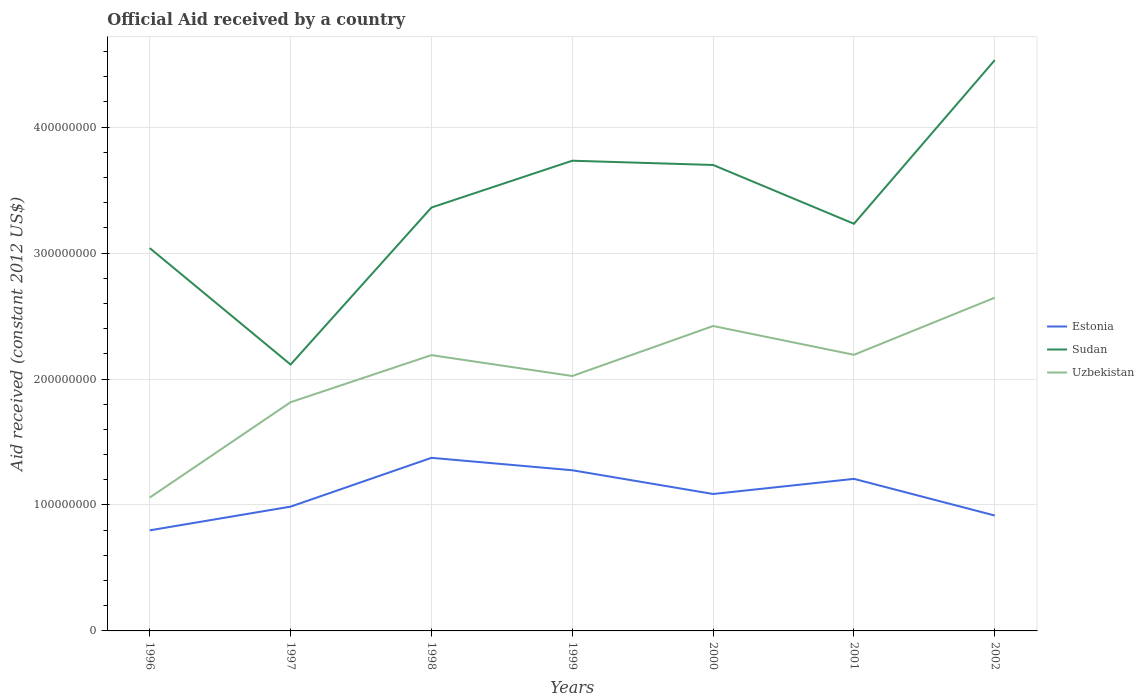Does the line corresponding to Estonia intersect with the line corresponding to Sudan?
Ensure brevity in your answer.  No. Across all years, what is the maximum net official aid received in Estonia?
Provide a short and direct response. 7.99e+07. What is the total net official aid received in Estonia in the graph?
Your answer should be compact. 1.67e+07. What is the difference between the highest and the second highest net official aid received in Estonia?
Offer a terse response. 5.76e+07. What is the difference between two consecutive major ticks on the Y-axis?
Offer a terse response. 1.00e+08. Does the graph contain any zero values?
Give a very brief answer. No. What is the title of the graph?
Make the answer very short. Official Aid received by a country. Does "Marshall Islands" appear as one of the legend labels in the graph?
Your response must be concise. No. What is the label or title of the Y-axis?
Provide a succinct answer. Aid received (constant 2012 US$). What is the Aid received (constant 2012 US$) in Estonia in 1996?
Make the answer very short. 7.99e+07. What is the Aid received (constant 2012 US$) in Sudan in 1996?
Your response must be concise. 3.04e+08. What is the Aid received (constant 2012 US$) of Uzbekistan in 1996?
Your answer should be compact. 1.06e+08. What is the Aid received (constant 2012 US$) in Estonia in 1997?
Provide a short and direct response. 9.87e+07. What is the Aid received (constant 2012 US$) of Sudan in 1997?
Provide a short and direct response. 2.12e+08. What is the Aid received (constant 2012 US$) of Uzbekistan in 1997?
Your answer should be compact. 1.82e+08. What is the Aid received (constant 2012 US$) in Estonia in 1998?
Offer a very short reply. 1.37e+08. What is the Aid received (constant 2012 US$) of Sudan in 1998?
Give a very brief answer. 3.36e+08. What is the Aid received (constant 2012 US$) of Uzbekistan in 1998?
Ensure brevity in your answer.  2.19e+08. What is the Aid received (constant 2012 US$) of Estonia in 1999?
Provide a short and direct response. 1.28e+08. What is the Aid received (constant 2012 US$) in Sudan in 1999?
Your answer should be very brief. 3.73e+08. What is the Aid received (constant 2012 US$) of Uzbekistan in 1999?
Ensure brevity in your answer.  2.02e+08. What is the Aid received (constant 2012 US$) in Estonia in 2000?
Give a very brief answer. 1.09e+08. What is the Aid received (constant 2012 US$) of Sudan in 2000?
Your answer should be compact. 3.70e+08. What is the Aid received (constant 2012 US$) in Uzbekistan in 2000?
Your answer should be compact. 2.42e+08. What is the Aid received (constant 2012 US$) in Estonia in 2001?
Provide a short and direct response. 1.21e+08. What is the Aid received (constant 2012 US$) of Sudan in 2001?
Offer a very short reply. 3.23e+08. What is the Aid received (constant 2012 US$) in Uzbekistan in 2001?
Provide a succinct answer. 2.19e+08. What is the Aid received (constant 2012 US$) in Estonia in 2002?
Offer a very short reply. 9.16e+07. What is the Aid received (constant 2012 US$) in Sudan in 2002?
Make the answer very short. 4.53e+08. What is the Aid received (constant 2012 US$) of Uzbekistan in 2002?
Make the answer very short. 2.65e+08. Across all years, what is the maximum Aid received (constant 2012 US$) of Estonia?
Provide a short and direct response. 1.37e+08. Across all years, what is the maximum Aid received (constant 2012 US$) in Sudan?
Offer a terse response. 4.53e+08. Across all years, what is the maximum Aid received (constant 2012 US$) in Uzbekistan?
Provide a succinct answer. 2.65e+08. Across all years, what is the minimum Aid received (constant 2012 US$) in Estonia?
Give a very brief answer. 7.99e+07. Across all years, what is the minimum Aid received (constant 2012 US$) of Sudan?
Give a very brief answer. 2.12e+08. Across all years, what is the minimum Aid received (constant 2012 US$) in Uzbekistan?
Provide a short and direct response. 1.06e+08. What is the total Aid received (constant 2012 US$) in Estonia in the graph?
Give a very brief answer. 7.65e+08. What is the total Aid received (constant 2012 US$) in Sudan in the graph?
Make the answer very short. 2.37e+09. What is the total Aid received (constant 2012 US$) in Uzbekistan in the graph?
Your response must be concise. 1.43e+09. What is the difference between the Aid received (constant 2012 US$) of Estonia in 1996 and that in 1997?
Your response must be concise. -1.88e+07. What is the difference between the Aid received (constant 2012 US$) in Sudan in 1996 and that in 1997?
Provide a short and direct response. 9.25e+07. What is the difference between the Aid received (constant 2012 US$) of Uzbekistan in 1996 and that in 1997?
Offer a terse response. -7.57e+07. What is the difference between the Aid received (constant 2012 US$) of Estonia in 1996 and that in 1998?
Provide a short and direct response. -5.76e+07. What is the difference between the Aid received (constant 2012 US$) in Sudan in 1996 and that in 1998?
Provide a succinct answer. -3.22e+07. What is the difference between the Aid received (constant 2012 US$) in Uzbekistan in 1996 and that in 1998?
Your answer should be very brief. -1.13e+08. What is the difference between the Aid received (constant 2012 US$) in Estonia in 1996 and that in 1999?
Offer a terse response. -4.77e+07. What is the difference between the Aid received (constant 2012 US$) of Sudan in 1996 and that in 1999?
Your answer should be compact. -6.94e+07. What is the difference between the Aid received (constant 2012 US$) in Uzbekistan in 1996 and that in 1999?
Your answer should be compact. -9.65e+07. What is the difference between the Aid received (constant 2012 US$) in Estonia in 1996 and that in 2000?
Your answer should be compact. -2.89e+07. What is the difference between the Aid received (constant 2012 US$) of Sudan in 1996 and that in 2000?
Your answer should be very brief. -6.60e+07. What is the difference between the Aid received (constant 2012 US$) in Uzbekistan in 1996 and that in 2000?
Keep it short and to the point. -1.36e+08. What is the difference between the Aid received (constant 2012 US$) of Estonia in 1996 and that in 2001?
Offer a terse response. -4.09e+07. What is the difference between the Aid received (constant 2012 US$) in Sudan in 1996 and that in 2001?
Provide a short and direct response. -1.93e+07. What is the difference between the Aid received (constant 2012 US$) of Uzbekistan in 1996 and that in 2001?
Give a very brief answer. -1.13e+08. What is the difference between the Aid received (constant 2012 US$) of Estonia in 1996 and that in 2002?
Your answer should be compact. -1.18e+07. What is the difference between the Aid received (constant 2012 US$) of Sudan in 1996 and that in 2002?
Give a very brief answer. -1.49e+08. What is the difference between the Aid received (constant 2012 US$) in Uzbekistan in 1996 and that in 2002?
Give a very brief answer. -1.59e+08. What is the difference between the Aid received (constant 2012 US$) of Estonia in 1997 and that in 1998?
Your answer should be very brief. -3.88e+07. What is the difference between the Aid received (constant 2012 US$) in Sudan in 1997 and that in 1998?
Offer a very short reply. -1.25e+08. What is the difference between the Aid received (constant 2012 US$) in Uzbekistan in 1997 and that in 1998?
Keep it short and to the point. -3.74e+07. What is the difference between the Aid received (constant 2012 US$) of Estonia in 1997 and that in 1999?
Offer a terse response. -2.89e+07. What is the difference between the Aid received (constant 2012 US$) of Sudan in 1997 and that in 1999?
Your response must be concise. -1.62e+08. What is the difference between the Aid received (constant 2012 US$) in Uzbekistan in 1997 and that in 1999?
Ensure brevity in your answer.  -2.08e+07. What is the difference between the Aid received (constant 2012 US$) of Estonia in 1997 and that in 2000?
Your answer should be very brief. -1.00e+07. What is the difference between the Aid received (constant 2012 US$) in Sudan in 1997 and that in 2000?
Keep it short and to the point. -1.58e+08. What is the difference between the Aid received (constant 2012 US$) in Uzbekistan in 1997 and that in 2000?
Give a very brief answer. -6.05e+07. What is the difference between the Aid received (constant 2012 US$) in Estonia in 1997 and that in 2001?
Ensure brevity in your answer.  -2.20e+07. What is the difference between the Aid received (constant 2012 US$) of Sudan in 1997 and that in 2001?
Offer a very short reply. -1.12e+08. What is the difference between the Aid received (constant 2012 US$) in Uzbekistan in 1997 and that in 2001?
Offer a very short reply. -3.76e+07. What is the difference between the Aid received (constant 2012 US$) of Estonia in 1997 and that in 2002?
Make the answer very short. 7.07e+06. What is the difference between the Aid received (constant 2012 US$) in Sudan in 1997 and that in 2002?
Your answer should be very brief. -2.42e+08. What is the difference between the Aid received (constant 2012 US$) of Uzbekistan in 1997 and that in 2002?
Your answer should be very brief. -8.30e+07. What is the difference between the Aid received (constant 2012 US$) of Estonia in 1998 and that in 1999?
Provide a succinct answer. 9.86e+06. What is the difference between the Aid received (constant 2012 US$) of Sudan in 1998 and that in 1999?
Give a very brief answer. -3.72e+07. What is the difference between the Aid received (constant 2012 US$) in Uzbekistan in 1998 and that in 1999?
Provide a short and direct response. 1.66e+07. What is the difference between the Aid received (constant 2012 US$) of Estonia in 1998 and that in 2000?
Make the answer very short. 2.87e+07. What is the difference between the Aid received (constant 2012 US$) of Sudan in 1998 and that in 2000?
Your response must be concise. -3.38e+07. What is the difference between the Aid received (constant 2012 US$) in Uzbekistan in 1998 and that in 2000?
Your answer should be compact. -2.31e+07. What is the difference between the Aid received (constant 2012 US$) of Estonia in 1998 and that in 2001?
Your response must be concise. 1.67e+07. What is the difference between the Aid received (constant 2012 US$) of Sudan in 1998 and that in 2001?
Offer a terse response. 1.29e+07. What is the difference between the Aid received (constant 2012 US$) in Uzbekistan in 1998 and that in 2001?
Your answer should be very brief. -2.70e+05. What is the difference between the Aid received (constant 2012 US$) in Estonia in 1998 and that in 2002?
Give a very brief answer. 4.58e+07. What is the difference between the Aid received (constant 2012 US$) of Sudan in 1998 and that in 2002?
Your answer should be compact. -1.17e+08. What is the difference between the Aid received (constant 2012 US$) in Uzbekistan in 1998 and that in 2002?
Keep it short and to the point. -4.56e+07. What is the difference between the Aid received (constant 2012 US$) of Estonia in 1999 and that in 2000?
Make the answer very short. 1.88e+07. What is the difference between the Aid received (constant 2012 US$) of Sudan in 1999 and that in 2000?
Give a very brief answer. 3.39e+06. What is the difference between the Aid received (constant 2012 US$) of Uzbekistan in 1999 and that in 2000?
Your answer should be compact. -3.97e+07. What is the difference between the Aid received (constant 2012 US$) of Estonia in 1999 and that in 2001?
Provide a short and direct response. 6.84e+06. What is the difference between the Aid received (constant 2012 US$) in Sudan in 1999 and that in 2001?
Your response must be concise. 5.01e+07. What is the difference between the Aid received (constant 2012 US$) of Uzbekistan in 1999 and that in 2001?
Make the answer very short. -1.68e+07. What is the difference between the Aid received (constant 2012 US$) in Estonia in 1999 and that in 2002?
Keep it short and to the point. 3.60e+07. What is the difference between the Aid received (constant 2012 US$) of Sudan in 1999 and that in 2002?
Ensure brevity in your answer.  -7.99e+07. What is the difference between the Aid received (constant 2012 US$) of Uzbekistan in 1999 and that in 2002?
Provide a succinct answer. -6.22e+07. What is the difference between the Aid received (constant 2012 US$) of Estonia in 2000 and that in 2001?
Ensure brevity in your answer.  -1.20e+07. What is the difference between the Aid received (constant 2012 US$) in Sudan in 2000 and that in 2001?
Provide a succinct answer. 4.67e+07. What is the difference between the Aid received (constant 2012 US$) in Uzbekistan in 2000 and that in 2001?
Provide a succinct answer. 2.29e+07. What is the difference between the Aid received (constant 2012 US$) in Estonia in 2000 and that in 2002?
Ensure brevity in your answer.  1.71e+07. What is the difference between the Aid received (constant 2012 US$) in Sudan in 2000 and that in 2002?
Make the answer very short. -8.33e+07. What is the difference between the Aid received (constant 2012 US$) of Uzbekistan in 2000 and that in 2002?
Give a very brief answer. -2.25e+07. What is the difference between the Aid received (constant 2012 US$) in Estonia in 2001 and that in 2002?
Offer a terse response. 2.91e+07. What is the difference between the Aid received (constant 2012 US$) in Sudan in 2001 and that in 2002?
Your response must be concise. -1.30e+08. What is the difference between the Aid received (constant 2012 US$) of Uzbekistan in 2001 and that in 2002?
Provide a succinct answer. -4.54e+07. What is the difference between the Aid received (constant 2012 US$) in Estonia in 1996 and the Aid received (constant 2012 US$) in Sudan in 1997?
Keep it short and to the point. -1.32e+08. What is the difference between the Aid received (constant 2012 US$) in Estonia in 1996 and the Aid received (constant 2012 US$) in Uzbekistan in 1997?
Make the answer very short. -1.02e+08. What is the difference between the Aid received (constant 2012 US$) of Sudan in 1996 and the Aid received (constant 2012 US$) of Uzbekistan in 1997?
Your response must be concise. 1.22e+08. What is the difference between the Aid received (constant 2012 US$) of Estonia in 1996 and the Aid received (constant 2012 US$) of Sudan in 1998?
Ensure brevity in your answer.  -2.56e+08. What is the difference between the Aid received (constant 2012 US$) in Estonia in 1996 and the Aid received (constant 2012 US$) in Uzbekistan in 1998?
Give a very brief answer. -1.39e+08. What is the difference between the Aid received (constant 2012 US$) of Sudan in 1996 and the Aid received (constant 2012 US$) of Uzbekistan in 1998?
Offer a terse response. 8.50e+07. What is the difference between the Aid received (constant 2012 US$) in Estonia in 1996 and the Aid received (constant 2012 US$) in Sudan in 1999?
Ensure brevity in your answer.  -2.94e+08. What is the difference between the Aid received (constant 2012 US$) in Estonia in 1996 and the Aid received (constant 2012 US$) in Uzbekistan in 1999?
Make the answer very short. -1.23e+08. What is the difference between the Aid received (constant 2012 US$) of Sudan in 1996 and the Aid received (constant 2012 US$) of Uzbekistan in 1999?
Your answer should be compact. 1.02e+08. What is the difference between the Aid received (constant 2012 US$) of Estonia in 1996 and the Aid received (constant 2012 US$) of Sudan in 2000?
Offer a terse response. -2.90e+08. What is the difference between the Aid received (constant 2012 US$) of Estonia in 1996 and the Aid received (constant 2012 US$) of Uzbekistan in 2000?
Keep it short and to the point. -1.62e+08. What is the difference between the Aid received (constant 2012 US$) of Sudan in 1996 and the Aid received (constant 2012 US$) of Uzbekistan in 2000?
Keep it short and to the point. 6.18e+07. What is the difference between the Aid received (constant 2012 US$) of Estonia in 1996 and the Aid received (constant 2012 US$) of Sudan in 2001?
Your answer should be very brief. -2.43e+08. What is the difference between the Aid received (constant 2012 US$) in Estonia in 1996 and the Aid received (constant 2012 US$) in Uzbekistan in 2001?
Offer a terse response. -1.39e+08. What is the difference between the Aid received (constant 2012 US$) of Sudan in 1996 and the Aid received (constant 2012 US$) of Uzbekistan in 2001?
Keep it short and to the point. 8.47e+07. What is the difference between the Aid received (constant 2012 US$) of Estonia in 1996 and the Aid received (constant 2012 US$) of Sudan in 2002?
Offer a very short reply. -3.73e+08. What is the difference between the Aid received (constant 2012 US$) in Estonia in 1996 and the Aid received (constant 2012 US$) in Uzbekistan in 2002?
Your answer should be compact. -1.85e+08. What is the difference between the Aid received (constant 2012 US$) of Sudan in 1996 and the Aid received (constant 2012 US$) of Uzbekistan in 2002?
Your answer should be very brief. 3.93e+07. What is the difference between the Aid received (constant 2012 US$) in Estonia in 1997 and the Aid received (constant 2012 US$) in Sudan in 1998?
Make the answer very short. -2.38e+08. What is the difference between the Aid received (constant 2012 US$) in Estonia in 1997 and the Aid received (constant 2012 US$) in Uzbekistan in 1998?
Your answer should be very brief. -1.20e+08. What is the difference between the Aid received (constant 2012 US$) in Sudan in 1997 and the Aid received (constant 2012 US$) in Uzbekistan in 1998?
Give a very brief answer. -7.48e+06. What is the difference between the Aid received (constant 2012 US$) in Estonia in 1997 and the Aid received (constant 2012 US$) in Sudan in 1999?
Provide a short and direct response. -2.75e+08. What is the difference between the Aid received (constant 2012 US$) in Estonia in 1997 and the Aid received (constant 2012 US$) in Uzbekistan in 1999?
Give a very brief answer. -1.04e+08. What is the difference between the Aid received (constant 2012 US$) in Sudan in 1997 and the Aid received (constant 2012 US$) in Uzbekistan in 1999?
Give a very brief answer. 9.10e+06. What is the difference between the Aid received (constant 2012 US$) of Estonia in 1997 and the Aid received (constant 2012 US$) of Sudan in 2000?
Provide a short and direct response. -2.71e+08. What is the difference between the Aid received (constant 2012 US$) in Estonia in 1997 and the Aid received (constant 2012 US$) in Uzbekistan in 2000?
Provide a short and direct response. -1.43e+08. What is the difference between the Aid received (constant 2012 US$) of Sudan in 1997 and the Aid received (constant 2012 US$) of Uzbekistan in 2000?
Make the answer very short. -3.06e+07. What is the difference between the Aid received (constant 2012 US$) of Estonia in 1997 and the Aid received (constant 2012 US$) of Sudan in 2001?
Make the answer very short. -2.25e+08. What is the difference between the Aid received (constant 2012 US$) in Estonia in 1997 and the Aid received (constant 2012 US$) in Uzbekistan in 2001?
Ensure brevity in your answer.  -1.21e+08. What is the difference between the Aid received (constant 2012 US$) in Sudan in 1997 and the Aid received (constant 2012 US$) in Uzbekistan in 2001?
Make the answer very short. -7.75e+06. What is the difference between the Aid received (constant 2012 US$) of Estonia in 1997 and the Aid received (constant 2012 US$) of Sudan in 2002?
Keep it short and to the point. -3.55e+08. What is the difference between the Aid received (constant 2012 US$) in Estonia in 1997 and the Aid received (constant 2012 US$) in Uzbekistan in 2002?
Offer a very short reply. -1.66e+08. What is the difference between the Aid received (constant 2012 US$) in Sudan in 1997 and the Aid received (constant 2012 US$) in Uzbekistan in 2002?
Ensure brevity in your answer.  -5.31e+07. What is the difference between the Aid received (constant 2012 US$) in Estonia in 1998 and the Aid received (constant 2012 US$) in Sudan in 1999?
Offer a very short reply. -2.36e+08. What is the difference between the Aid received (constant 2012 US$) of Estonia in 1998 and the Aid received (constant 2012 US$) of Uzbekistan in 1999?
Your answer should be compact. -6.50e+07. What is the difference between the Aid received (constant 2012 US$) in Sudan in 1998 and the Aid received (constant 2012 US$) in Uzbekistan in 1999?
Provide a short and direct response. 1.34e+08. What is the difference between the Aid received (constant 2012 US$) in Estonia in 1998 and the Aid received (constant 2012 US$) in Sudan in 2000?
Your response must be concise. -2.33e+08. What is the difference between the Aid received (constant 2012 US$) of Estonia in 1998 and the Aid received (constant 2012 US$) of Uzbekistan in 2000?
Make the answer very short. -1.05e+08. What is the difference between the Aid received (constant 2012 US$) of Sudan in 1998 and the Aid received (constant 2012 US$) of Uzbekistan in 2000?
Offer a very short reply. 9.41e+07. What is the difference between the Aid received (constant 2012 US$) of Estonia in 1998 and the Aid received (constant 2012 US$) of Sudan in 2001?
Provide a short and direct response. -1.86e+08. What is the difference between the Aid received (constant 2012 US$) in Estonia in 1998 and the Aid received (constant 2012 US$) in Uzbekistan in 2001?
Make the answer very short. -8.18e+07. What is the difference between the Aid received (constant 2012 US$) of Sudan in 1998 and the Aid received (constant 2012 US$) of Uzbekistan in 2001?
Provide a succinct answer. 1.17e+08. What is the difference between the Aid received (constant 2012 US$) in Estonia in 1998 and the Aid received (constant 2012 US$) in Sudan in 2002?
Make the answer very short. -3.16e+08. What is the difference between the Aid received (constant 2012 US$) of Estonia in 1998 and the Aid received (constant 2012 US$) of Uzbekistan in 2002?
Offer a terse response. -1.27e+08. What is the difference between the Aid received (constant 2012 US$) of Sudan in 1998 and the Aid received (constant 2012 US$) of Uzbekistan in 2002?
Make the answer very short. 7.16e+07. What is the difference between the Aid received (constant 2012 US$) in Estonia in 1999 and the Aid received (constant 2012 US$) in Sudan in 2000?
Your response must be concise. -2.42e+08. What is the difference between the Aid received (constant 2012 US$) in Estonia in 1999 and the Aid received (constant 2012 US$) in Uzbekistan in 2000?
Your answer should be very brief. -1.15e+08. What is the difference between the Aid received (constant 2012 US$) in Sudan in 1999 and the Aid received (constant 2012 US$) in Uzbekistan in 2000?
Provide a short and direct response. 1.31e+08. What is the difference between the Aid received (constant 2012 US$) of Estonia in 1999 and the Aid received (constant 2012 US$) of Sudan in 2001?
Provide a succinct answer. -1.96e+08. What is the difference between the Aid received (constant 2012 US$) in Estonia in 1999 and the Aid received (constant 2012 US$) in Uzbekistan in 2001?
Provide a succinct answer. -9.17e+07. What is the difference between the Aid received (constant 2012 US$) in Sudan in 1999 and the Aid received (constant 2012 US$) in Uzbekistan in 2001?
Offer a very short reply. 1.54e+08. What is the difference between the Aid received (constant 2012 US$) of Estonia in 1999 and the Aid received (constant 2012 US$) of Sudan in 2002?
Your answer should be compact. -3.26e+08. What is the difference between the Aid received (constant 2012 US$) in Estonia in 1999 and the Aid received (constant 2012 US$) in Uzbekistan in 2002?
Your answer should be compact. -1.37e+08. What is the difference between the Aid received (constant 2012 US$) in Sudan in 1999 and the Aid received (constant 2012 US$) in Uzbekistan in 2002?
Ensure brevity in your answer.  1.09e+08. What is the difference between the Aid received (constant 2012 US$) of Estonia in 2000 and the Aid received (constant 2012 US$) of Sudan in 2001?
Your answer should be compact. -2.15e+08. What is the difference between the Aid received (constant 2012 US$) of Estonia in 2000 and the Aid received (constant 2012 US$) of Uzbekistan in 2001?
Ensure brevity in your answer.  -1.11e+08. What is the difference between the Aid received (constant 2012 US$) in Sudan in 2000 and the Aid received (constant 2012 US$) in Uzbekistan in 2001?
Ensure brevity in your answer.  1.51e+08. What is the difference between the Aid received (constant 2012 US$) in Estonia in 2000 and the Aid received (constant 2012 US$) in Sudan in 2002?
Provide a succinct answer. -3.45e+08. What is the difference between the Aid received (constant 2012 US$) in Estonia in 2000 and the Aid received (constant 2012 US$) in Uzbekistan in 2002?
Your response must be concise. -1.56e+08. What is the difference between the Aid received (constant 2012 US$) of Sudan in 2000 and the Aid received (constant 2012 US$) of Uzbekistan in 2002?
Provide a short and direct response. 1.05e+08. What is the difference between the Aid received (constant 2012 US$) of Estonia in 2001 and the Aid received (constant 2012 US$) of Sudan in 2002?
Offer a terse response. -3.33e+08. What is the difference between the Aid received (constant 2012 US$) in Estonia in 2001 and the Aid received (constant 2012 US$) in Uzbekistan in 2002?
Offer a terse response. -1.44e+08. What is the difference between the Aid received (constant 2012 US$) of Sudan in 2001 and the Aid received (constant 2012 US$) of Uzbekistan in 2002?
Make the answer very short. 5.87e+07. What is the average Aid received (constant 2012 US$) in Estonia per year?
Provide a succinct answer. 1.09e+08. What is the average Aid received (constant 2012 US$) in Sudan per year?
Your answer should be very brief. 3.39e+08. What is the average Aid received (constant 2012 US$) of Uzbekistan per year?
Your response must be concise. 2.05e+08. In the year 1996, what is the difference between the Aid received (constant 2012 US$) in Estonia and Aid received (constant 2012 US$) in Sudan?
Your answer should be very brief. -2.24e+08. In the year 1996, what is the difference between the Aid received (constant 2012 US$) of Estonia and Aid received (constant 2012 US$) of Uzbekistan?
Give a very brief answer. -2.60e+07. In the year 1996, what is the difference between the Aid received (constant 2012 US$) of Sudan and Aid received (constant 2012 US$) of Uzbekistan?
Make the answer very short. 1.98e+08. In the year 1997, what is the difference between the Aid received (constant 2012 US$) of Estonia and Aid received (constant 2012 US$) of Sudan?
Offer a terse response. -1.13e+08. In the year 1997, what is the difference between the Aid received (constant 2012 US$) of Estonia and Aid received (constant 2012 US$) of Uzbekistan?
Provide a succinct answer. -8.29e+07. In the year 1997, what is the difference between the Aid received (constant 2012 US$) of Sudan and Aid received (constant 2012 US$) of Uzbekistan?
Give a very brief answer. 2.99e+07. In the year 1998, what is the difference between the Aid received (constant 2012 US$) of Estonia and Aid received (constant 2012 US$) of Sudan?
Ensure brevity in your answer.  -1.99e+08. In the year 1998, what is the difference between the Aid received (constant 2012 US$) of Estonia and Aid received (constant 2012 US$) of Uzbekistan?
Offer a terse response. -8.16e+07. In the year 1998, what is the difference between the Aid received (constant 2012 US$) of Sudan and Aid received (constant 2012 US$) of Uzbekistan?
Your answer should be very brief. 1.17e+08. In the year 1999, what is the difference between the Aid received (constant 2012 US$) in Estonia and Aid received (constant 2012 US$) in Sudan?
Keep it short and to the point. -2.46e+08. In the year 1999, what is the difference between the Aid received (constant 2012 US$) in Estonia and Aid received (constant 2012 US$) in Uzbekistan?
Ensure brevity in your answer.  -7.48e+07. In the year 1999, what is the difference between the Aid received (constant 2012 US$) of Sudan and Aid received (constant 2012 US$) of Uzbekistan?
Your answer should be very brief. 1.71e+08. In the year 2000, what is the difference between the Aid received (constant 2012 US$) in Estonia and Aid received (constant 2012 US$) in Sudan?
Your answer should be compact. -2.61e+08. In the year 2000, what is the difference between the Aid received (constant 2012 US$) of Estonia and Aid received (constant 2012 US$) of Uzbekistan?
Your answer should be compact. -1.33e+08. In the year 2000, what is the difference between the Aid received (constant 2012 US$) of Sudan and Aid received (constant 2012 US$) of Uzbekistan?
Your response must be concise. 1.28e+08. In the year 2001, what is the difference between the Aid received (constant 2012 US$) of Estonia and Aid received (constant 2012 US$) of Sudan?
Provide a short and direct response. -2.03e+08. In the year 2001, what is the difference between the Aid received (constant 2012 US$) of Estonia and Aid received (constant 2012 US$) of Uzbekistan?
Offer a terse response. -9.85e+07. In the year 2001, what is the difference between the Aid received (constant 2012 US$) in Sudan and Aid received (constant 2012 US$) in Uzbekistan?
Offer a terse response. 1.04e+08. In the year 2002, what is the difference between the Aid received (constant 2012 US$) of Estonia and Aid received (constant 2012 US$) of Sudan?
Your answer should be compact. -3.62e+08. In the year 2002, what is the difference between the Aid received (constant 2012 US$) in Estonia and Aid received (constant 2012 US$) in Uzbekistan?
Your answer should be very brief. -1.73e+08. In the year 2002, what is the difference between the Aid received (constant 2012 US$) of Sudan and Aid received (constant 2012 US$) of Uzbekistan?
Offer a very short reply. 1.89e+08. What is the ratio of the Aid received (constant 2012 US$) of Estonia in 1996 to that in 1997?
Keep it short and to the point. 0.81. What is the ratio of the Aid received (constant 2012 US$) of Sudan in 1996 to that in 1997?
Your answer should be very brief. 1.44. What is the ratio of the Aid received (constant 2012 US$) in Uzbekistan in 1996 to that in 1997?
Offer a terse response. 0.58. What is the ratio of the Aid received (constant 2012 US$) in Estonia in 1996 to that in 1998?
Give a very brief answer. 0.58. What is the ratio of the Aid received (constant 2012 US$) in Sudan in 1996 to that in 1998?
Provide a succinct answer. 0.9. What is the ratio of the Aid received (constant 2012 US$) in Uzbekistan in 1996 to that in 1998?
Make the answer very short. 0.48. What is the ratio of the Aid received (constant 2012 US$) in Estonia in 1996 to that in 1999?
Offer a terse response. 0.63. What is the ratio of the Aid received (constant 2012 US$) of Sudan in 1996 to that in 1999?
Provide a succinct answer. 0.81. What is the ratio of the Aid received (constant 2012 US$) in Uzbekistan in 1996 to that in 1999?
Your answer should be very brief. 0.52. What is the ratio of the Aid received (constant 2012 US$) in Estonia in 1996 to that in 2000?
Give a very brief answer. 0.73. What is the ratio of the Aid received (constant 2012 US$) of Sudan in 1996 to that in 2000?
Your answer should be very brief. 0.82. What is the ratio of the Aid received (constant 2012 US$) of Uzbekistan in 1996 to that in 2000?
Offer a very short reply. 0.44. What is the ratio of the Aid received (constant 2012 US$) of Estonia in 1996 to that in 2001?
Your answer should be compact. 0.66. What is the ratio of the Aid received (constant 2012 US$) in Sudan in 1996 to that in 2001?
Make the answer very short. 0.94. What is the ratio of the Aid received (constant 2012 US$) of Uzbekistan in 1996 to that in 2001?
Keep it short and to the point. 0.48. What is the ratio of the Aid received (constant 2012 US$) in Estonia in 1996 to that in 2002?
Provide a succinct answer. 0.87. What is the ratio of the Aid received (constant 2012 US$) of Sudan in 1996 to that in 2002?
Provide a succinct answer. 0.67. What is the ratio of the Aid received (constant 2012 US$) of Uzbekistan in 1996 to that in 2002?
Provide a succinct answer. 0.4. What is the ratio of the Aid received (constant 2012 US$) of Estonia in 1997 to that in 1998?
Keep it short and to the point. 0.72. What is the ratio of the Aid received (constant 2012 US$) in Sudan in 1997 to that in 1998?
Make the answer very short. 0.63. What is the ratio of the Aid received (constant 2012 US$) of Uzbekistan in 1997 to that in 1998?
Make the answer very short. 0.83. What is the ratio of the Aid received (constant 2012 US$) of Estonia in 1997 to that in 1999?
Your answer should be very brief. 0.77. What is the ratio of the Aid received (constant 2012 US$) of Sudan in 1997 to that in 1999?
Your answer should be compact. 0.57. What is the ratio of the Aid received (constant 2012 US$) of Uzbekistan in 1997 to that in 1999?
Your answer should be very brief. 0.9. What is the ratio of the Aid received (constant 2012 US$) in Estonia in 1997 to that in 2000?
Give a very brief answer. 0.91. What is the ratio of the Aid received (constant 2012 US$) of Sudan in 1997 to that in 2000?
Your answer should be very brief. 0.57. What is the ratio of the Aid received (constant 2012 US$) in Uzbekistan in 1997 to that in 2000?
Your answer should be very brief. 0.75. What is the ratio of the Aid received (constant 2012 US$) of Estonia in 1997 to that in 2001?
Offer a terse response. 0.82. What is the ratio of the Aid received (constant 2012 US$) in Sudan in 1997 to that in 2001?
Provide a short and direct response. 0.65. What is the ratio of the Aid received (constant 2012 US$) in Uzbekistan in 1997 to that in 2001?
Provide a succinct answer. 0.83. What is the ratio of the Aid received (constant 2012 US$) in Estonia in 1997 to that in 2002?
Provide a short and direct response. 1.08. What is the ratio of the Aid received (constant 2012 US$) of Sudan in 1997 to that in 2002?
Provide a short and direct response. 0.47. What is the ratio of the Aid received (constant 2012 US$) of Uzbekistan in 1997 to that in 2002?
Your answer should be compact. 0.69. What is the ratio of the Aid received (constant 2012 US$) in Estonia in 1998 to that in 1999?
Offer a very short reply. 1.08. What is the ratio of the Aid received (constant 2012 US$) in Sudan in 1998 to that in 1999?
Give a very brief answer. 0.9. What is the ratio of the Aid received (constant 2012 US$) in Uzbekistan in 1998 to that in 1999?
Your response must be concise. 1.08. What is the ratio of the Aid received (constant 2012 US$) in Estonia in 1998 to that in 2000?
Provide a short and direct response. 1.26. What is the ratio of the Aid received (constant 2012 US$) of Sudan in 1998 to that in 2000?
Offer a terse response. 0.91. What is the ratio of the Aid received (constant 2012 US$) of Uzbekistan in 1998 to that in 2000?
Give a very brief answer. 0.9. What is the ratio of the Aid received (constant 2012 US$) in Estonia in 1998 to that in 2001?
Ensure brevity in your answer.  1.14. What is the ratio of the Aid received (constant 2012 US$) in Sudan in 1998 to that in 2001?
Offer a terse response. 1.04. What is the ratio of the Aid received (constant 2012 US$) in Uzbekistan in 1998 to that in 2001?
Your answer should be compact. 1. What is the ratio of the Aid received (constant 2012 US$) in Estonia in 1998 to that in 2002?
Offer a terse response. 1.5. What is the ratio of the Aid received (constant 2012 US$) of Sudan in 1998 to that in 2002?
Your answer should be compact. 0.74. What is the ratio of the Aid received (constant 2012 US$) in Uzbekistan in 1998 to that in 2002?
Your response must be concise. 0.83. What is the ratio of the Aid received (constant 2012 US$) of Estonia in 1999 to that in 2000?
Keep it short and to the point. 1.17. What is the ratio of the Aid received (constant 2012 US$) in Sudan in 1999 to that in 2000?
Your response must be concise. 1.01. What is the ratio of the Aid received (constant 2012 US$) of Uzbekistan in 1999 to that in 2000?
Offer a very short reply. 0.84. What is the ratio of the Aid received (constant 2012 US$) in Estonia in 1999 to that in 2001?
Your answer should be very brief. 1.06. What is the ratio of the Aid received (constant 2012 US$) in Sudan in 1999 to that in 2001?
Provide a short and direct response. 1.15. What is the ratio of the Aid received (constant 2012 US$) of Uzbekistan in 1999 to that in 2001?
Offer a terse response. 0.92. What is the ratio of the Aid received (constant 2012 US$) of Estonia in 1999 to that in 2002?
Keep it short and to the point. 1.39. What is the ratio of the Aid received (constant 2012 US$) in Sudan in 1999 to that in 2002?
Give a very brief answer. 0.82. What is the ratio of the Aid received (constant 2012 US$) in Uzbekistan in 1999 to that in 2002?
Offer a very short reply. 0.76. What is the ratio of the Aid received (constant 2012 US$) of Estonia in 2000 to that in 2001?
Your answer should be very brief. 0.9. What is the ratio of the Aid received (constant 2012 US$) in Sudan in 2000 to that in 2001?
Offer a terse response. 1.14. What is the ratio of the Aid received (constant 2012 US$) of Uzbekistan in 2000 to that in 2001?
Your answer should be compact. 1.1. What is the ratio of the Aid received (constant 2012 US$) of Estonia in 2000 to that in 2002?
Provide a succinct answer. 1.19. What is the ratio of the Aid received (constant 2012 US$) in Sudan in 2000 to that in 2002?
Keep it short and to the point. 0.82. What is the ratio of the Aid received (constant 2012 US$) of Uzbekistan in 2000 to that in 2002?
Offer a terse response. 0.91. What is the ratio of the Aid received (constant 2012 US$) of Estonia in 2001 to that in 2002?
Give a very brief answer. 1.32. What is the ratio of the Aid received (constant 2012 US$) of Sudan in 2001 to that in 2002?
Ensure brevity in your answer.  0.71. What is the ratio of the Aid received (constant 2012 US$) of Uzbekistan in 2001 to that in 2002?
Provide a succinct answer. 0.83. What is the difference between the highest and the second highest Aid received (constant 2012 US$) in Estonia?
Offer a very short reply. 9.86e+06. What is the difference between the highest and the second highest Aid received (constant 2012 US$) of Sudan?
Your response must be concise. 7.99e+07. What is the difference between the highest and the second highest Aid received (constant 2012 US$) of Uzbekistan?
Give a very brief answer. 2.25e+07. What is the difference between the highest and the lowest Aid received (constant 2012 US$) of Estonia?
Make the answer very short. 5.76e+07. What is the difference between the highest and the lowest Aid received (constant 2012 US$) of Sudan?
Provide a short and direct response. 2.42e+08. What is the difference between the highest and the lowest Aid received (constant 2012 US$) in Uzbekistan?
Your answer should be very brief. 1.59e+08. 